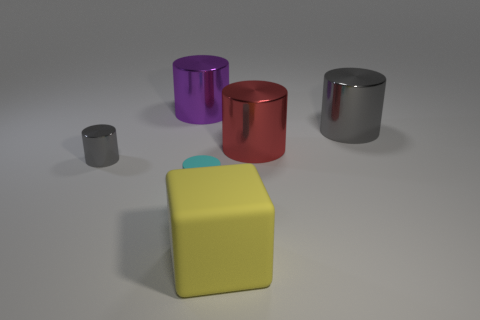There is a big yellow thing in front of the gray metal object that is right of the big yellow block in front of the small gray object; what shape is it? The big yellow object you're referring to is a cube. It's positioned in front of the gray metal cylindrical object and is indeed a larger counterpart to the smaller yellow cube, which is itself in front of a small gray cube. 